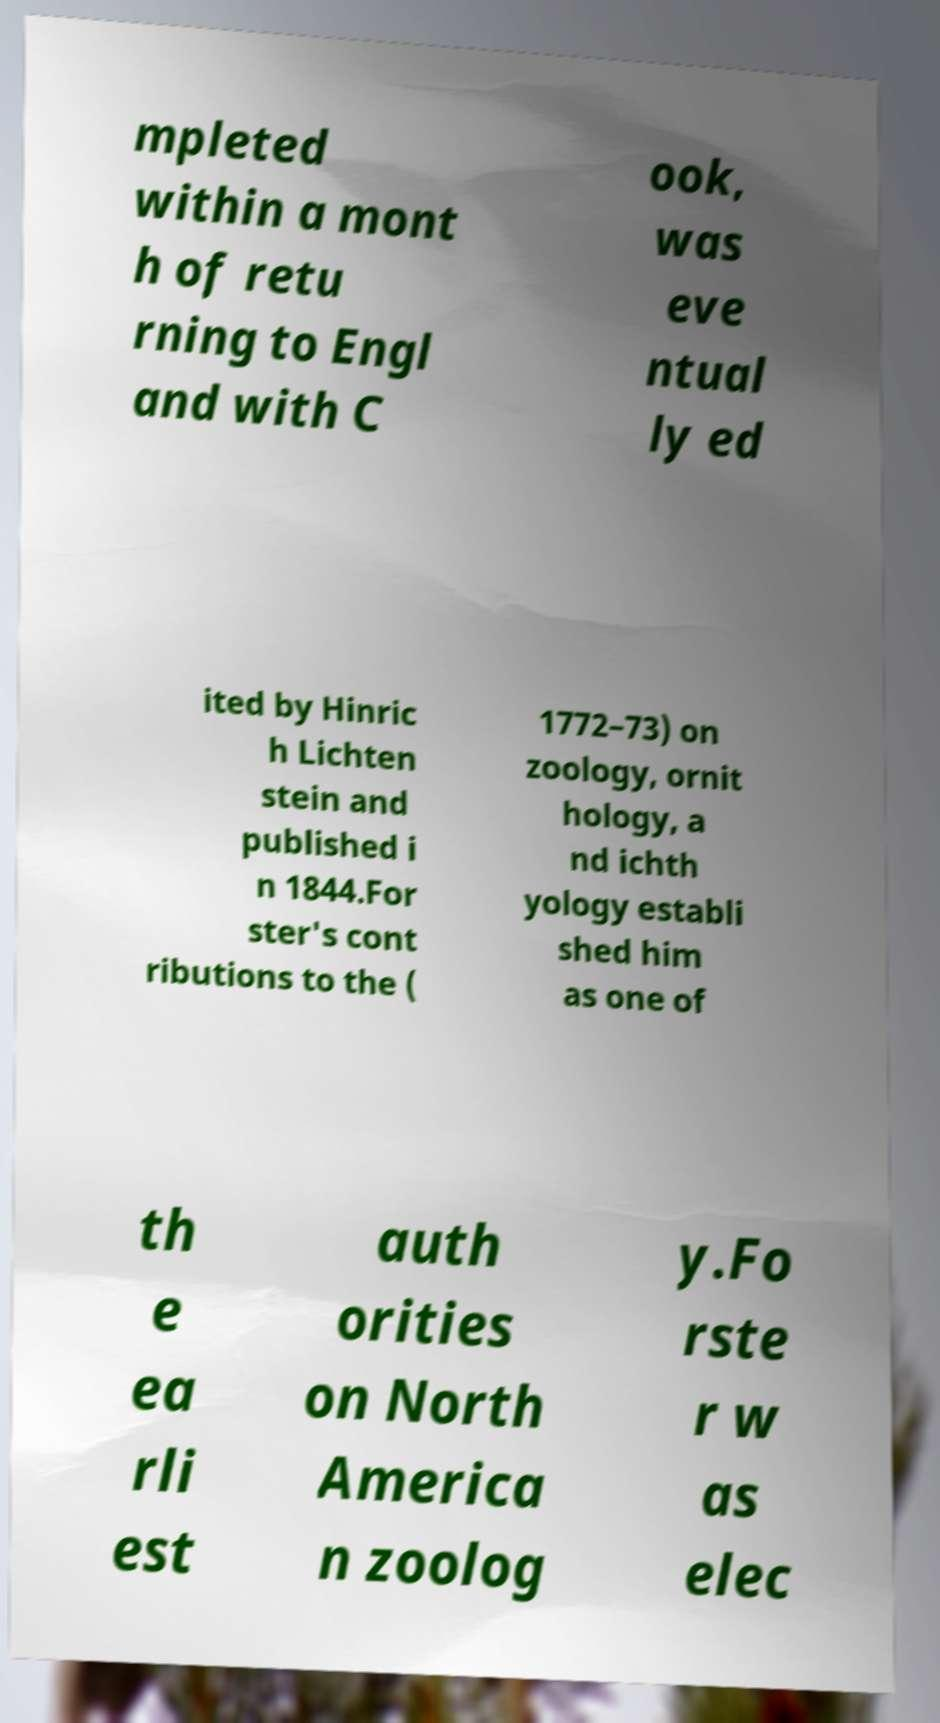Can you read and provide the text displayed in the image?This photo seems to have some interesting text. Can you extract and type it out for me? mpleted within a mont h of retu rning to Engl and with C ook, was eve ntual ly ed ited by Hinric h Lichten stein and published i n 1844.For ster's cont ributions to the ( 1772–73) on zoology, ornit hology, a nd ichth yology establi shed him as one of th e ea rli est auth orities on North America n zoolog y.Fo rste r w as elec 